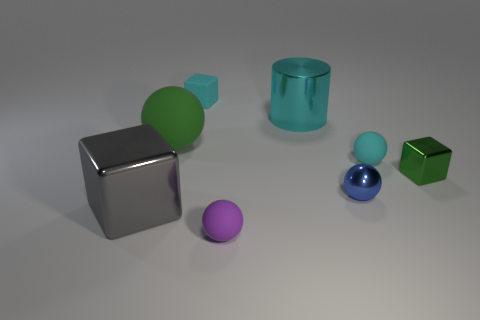Subtract all yellow balls. Subtract all gray cylinders. How many balls are left? 4 Add 1 large green matte cylinders. How many objects exist? 9 Subtract all blocks. How many objects are left? 5 Add 8 gray shiny objects. How many gray shiny objects exist? 9 Subtract 1 cyan blocks. How many objects are left? 7 Subtract all gray metal cylinders. Subtract all blue metallic objects. How many objects are left? 7 Add 3 green metal things. How many green metal things are left? 4 